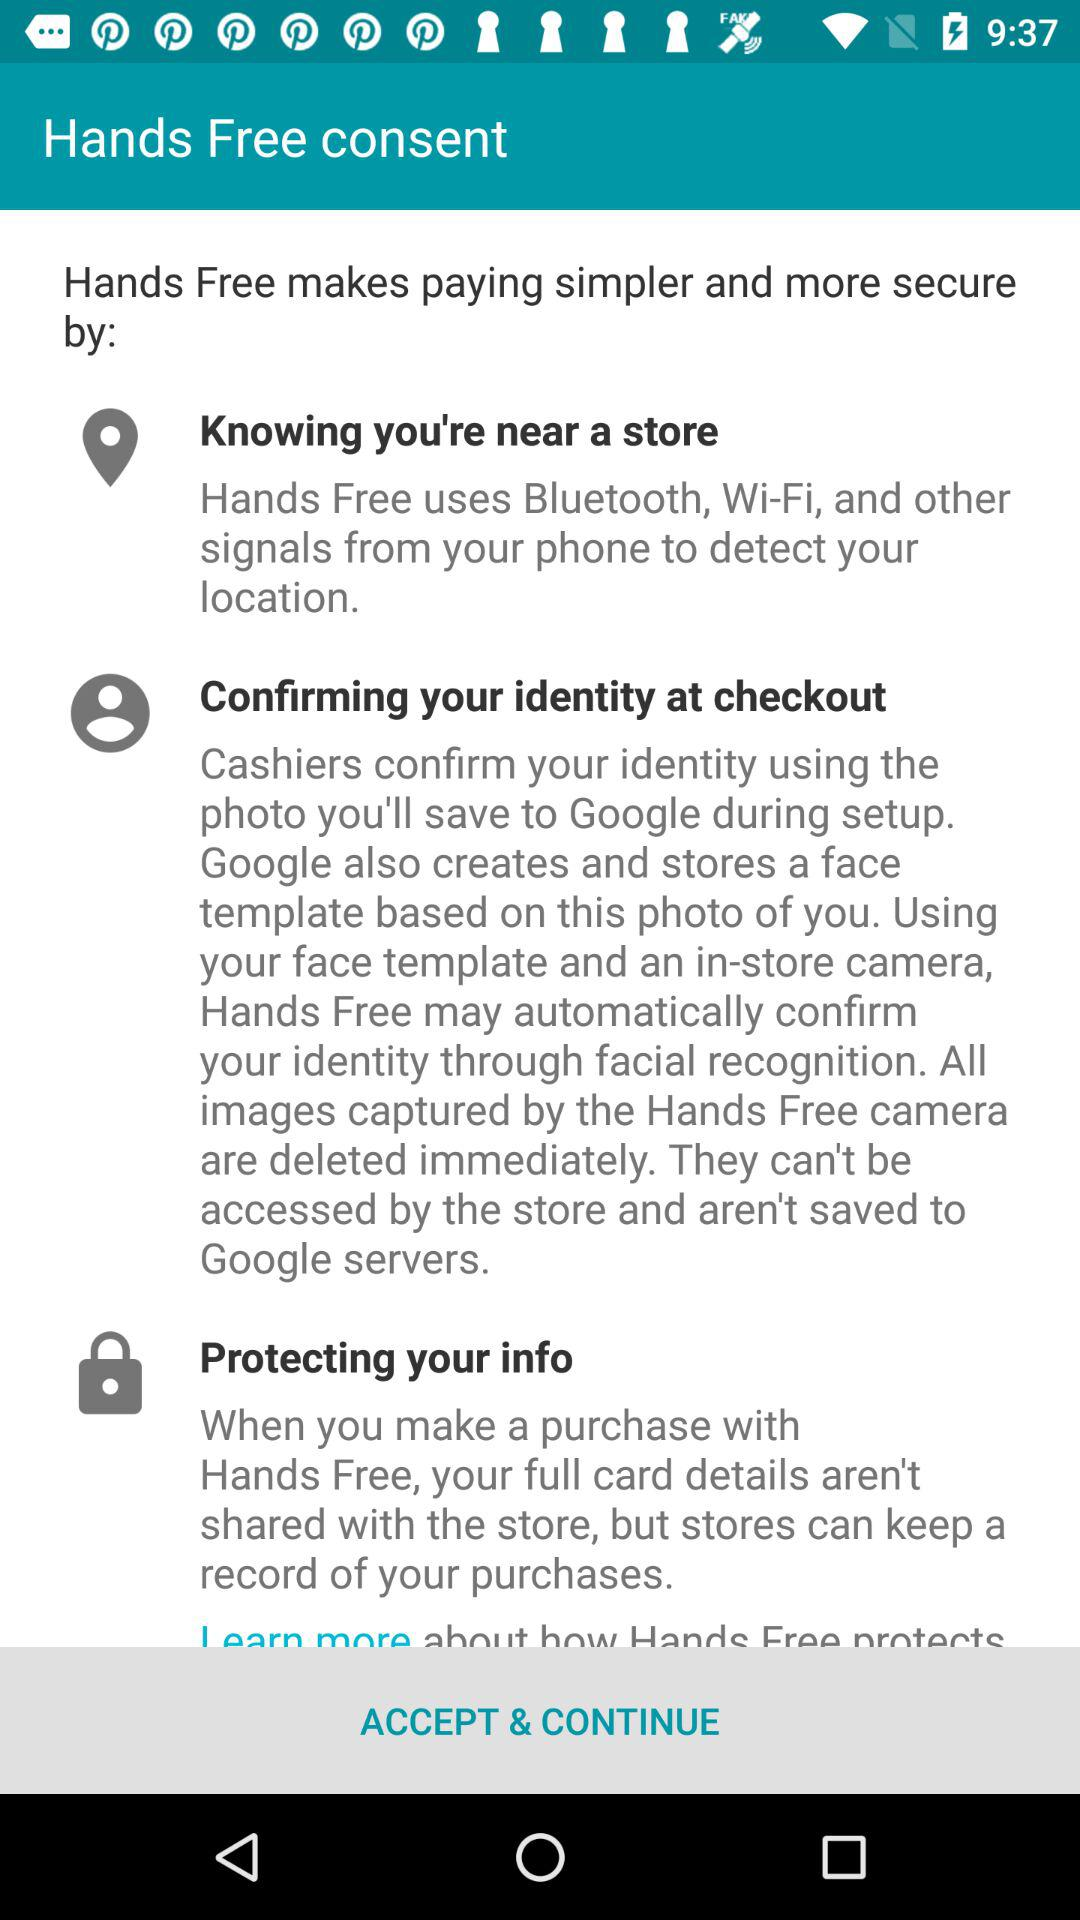What does the "Hands Free" application use? The "Hands Free" application uses Bluetooth, Wi-Fi, and other signals from your phone to detect your location. 